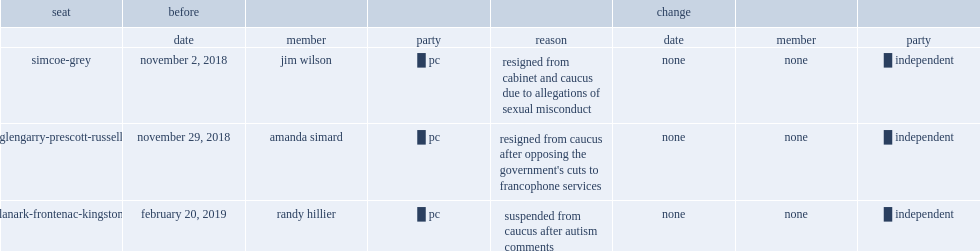When is progressive conservative randy hillier (lanark-frontenac-kingston) suspended from the pc caucus? February 20, 2019. 